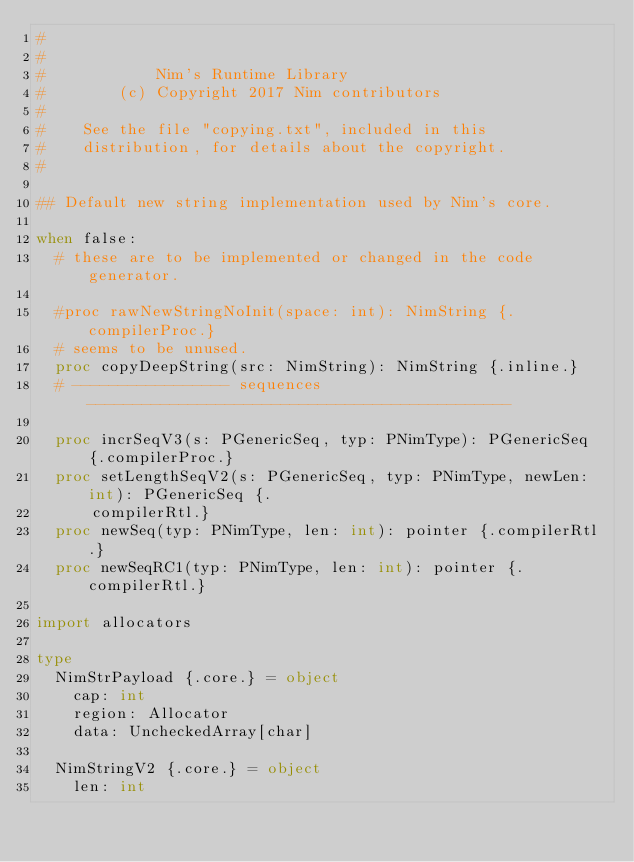Convert code to text. <code><loc_0><loc_0><loc_500><loc_500><_Nim_>#
#
#            Nim's Runtime Library
#        (c) Copyright 2017 Nim contributors
#
#    See the file "copying.txt", included in this
#    distribution, for details about the copyright.
#

## Default new string implementation used by Nim's core.

when false:
  # these are to be implemented or changed in the code generator.

  #proc rawNewStringNoInit(space: int): NimString {.compilerProc.}
  # seems to be unused.
  proc copyDeepString(src: NimString): NimString {.inline.}
  # ----------------- sequences ----------------------------------------------

  proc incrSeqV3(s: PGenericSeq, typ: PNimType): PGenericSeq {.compilerProc.}
  proc setLengthSeqV2(s: PGenericSeq, typ: PNimType, newLen: int): PGenericSeq {.
      compilerRtl.}
  proc newSeq(typ: PNimType, len: int): pointer {.compilerRtl.}
  proc newSeqRC1(typ: PNimType, len: int): pointer {.compilerRtl.}

import allocators

type
  NimStrPayload {.core.} = object
    cap: int
    region: Allocator
    data: UncheckedArray[char]

  NimStringV2 {.core.} = object
    len: int</code> 